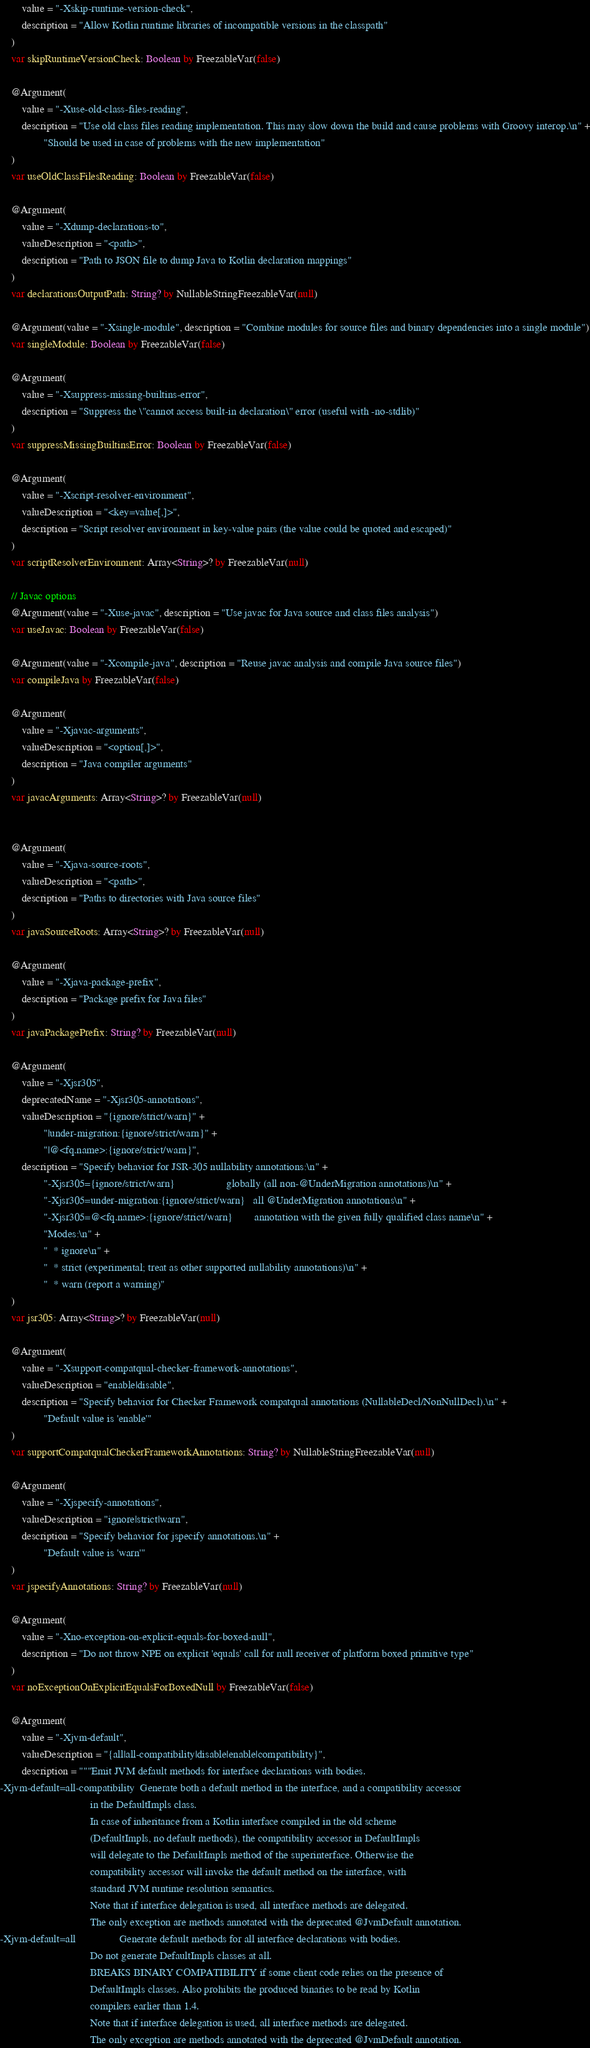<code> <loc_0><loc_0><loc_500><loc_500><_Kotlin_>        value = "-Xskip-runtime-version-check",
        description = "Allow Kotlin runtime libraries of incompatible versions in the classpath"
    )
    var skipRuntimeVersionCheck: Boolean by FreezableVar(false)

    @Argument(
        value = "-Xuse-old-class-files-reading",
        description = "Use old class files reading implementation. This may slow down the build and cause problems with Groovy interop.\n" +
                "Should be used in case of problems with the new implementation"
    )
    var useOldClassFilesReading: Boolean by FreezableVar(false)

    @Argument(
        value = "-Xdump-declarations-to",
        valueDescription = "<path>",
        description = "Path to JSON file to dump Java to Kotlin declaration mappings"
    )
    var declarationsOutputPath: String? by NullableStringFreezableVar(null)

    @Argument(value = "-Xsingle-module", description = "Combine modules for source files and binary dependencies into a single module")
    var singleModule: Boolean by FreezableVar(false)

    @Argument(
        value = "-Xsuppress-missing-builtins-error",
        description = "Suppress the \"cannot access built-in declaration\" error (useful with -no-stdlib)"
    )
    var suppressMissingBuiltinsError: Boolean by FreezableVar(false)

    @Argument(
        value = "-Xscript-resolver-environment",
        valueDescription = "<key=value[,]>",
        description = "Script resolver environment in key-value pairs (the value could be quoted and escaped)"
    )
    var scriptResolverEnvironment: Array<String>? by FreezableVar(null)

    // Javac options
    @Argument(value = "-Xuse-javac", description = "Use javac for Java source and class files analysis")
    var useJavac: Boolean by FreezableVar(false)

    @Argument(value = "-Xcompile-java", description = "Reuse javac analysis and compile Java source files")
    var compileJava by FreezableVar(false)

    @Argument(
        value = "-Xjavac-arguments",
        valueDescription = "<option[,]>",
        description = "Java compiler arguments"
    )
    var javacArguments: Array<String>? by FreezableVar(null)


    @Argument(
        value = "-Xjava-source-roots",
        valueDescription = "<path>",
        description = "Paths to directories with Java source files"
    )
    var javaSourceRoots: Array<String>? by FreezableVar(null)

    @Argument(
        value = "-Xjava-package-prefix",
        description = "Package prefix for Java files"
    )
    var javaPackagePrefix: String? by FreezableVar(null)

    @Argument(
        value = "-Xjsr305",
        deprecatedName = "-Xjsr305-annotations",
        valueDescription = "{ignore/strict/warn}" +
                "|under-migration:{ignore/strict/warn}" +
                "|@<fq.name>:{ignore/strict/warn}",
        description = "Specify behavior for JSR-305 nullability annotations:\n" +
                "-Xjsr305={ignore/strict/warn}                   globally (all non-@UnderMigration annotations)\n" +
                "-Xjsr305=under-migration:{ignore/strict/warn}   all @UnderMigration annotations\n" +
                "-Xjsr305=@<fq.name>:{ignore/strict/warn}        annotation with the given fully qualified class name\n" +
                "Modes:\n" +
                "  * ignore\n" +
                "  * strict (experimental; treat as other supported nullability annotations)\n" +
                "  * warn (report a warning)"
    )
    var jsr305: Array<String>? by FreezableVar(null)

    @Argument(
        value = "-Xsupport-compatqual-checker-framework-annotations",
        valueDescription = "enable|disable",
        description = "Specify behavior for Checker Framework compatqual annotations (NullableDecl/NonNullDecl).\n" +
                "Default value is 'enable'"
    )
    var supportCompatqualCheckerFrameworkAnnotations: String? by NullableStringFreezableVar(null)

    @Argument(
        value = "-Xjspecify-annotations",
        valueDescription = "ignore|strict|warn",
        description = "Specify behavior for jspecify annotations.\n" +
                "Default value is 'warn'"
    )
    var jspecifyAnnotations: String? by FreezableVar(null)

    @Argument(
        value = "-Xno-exception-on-explicit-equals-for-boxed-null",
        description = "Do not throw NPE on explicit 'equals' call for null receiver of platform boxed primitive type"
    )
    var noExceptionOnExplicitEqualsForBoxedNull by FreezableVar(false)

    @Argument(
        value = "-Xjvm-default",
        valueDescription = "{all|all-compatibility|disable|enable|compatibility}",
        description = """Emit JVM default methods for interface declarations with bodies.
-Xjvm-default=all-compatibility  Generate both a default method in the interface, and a compatibility accessor
                                 in the DefaultImpls class.
                                 In case of inheritance from a Kotlin interface compiled in the old scheme
                                 (DefaultImpls, no default methods), the compatibility accessor in DefaultImpls
                                 will delegate to the DefaultImpls method of the superinterface. Otherwise the
                                 compatibility accessor will invoke the default method on the interface, with
                                 standard JVM runtime resolution semantics.
                                 Note that if interface delegation is used, all interface methods are delegated.
                                 The only exception are methods annotated with the deprecated @JvmDefault annotation.
-Xjvm-default=all                Generate default methods for all interface declarations with bodies.
                                 Do not generate DefaultImpls classes at all.
                                 BREAKS BINARY COMPATIBILITY if some client code relies on the presence of
                                 DefaultImpls classes. Also prohibits the produced binaries to be read by Kotlin
                                 compilers earlier than 1.4.
                                 Note that if interface delegation is used, all interface methods are delegated.
                                 The only exception are methods annotated with the deprecated @JvmDefault annotation.</code> 